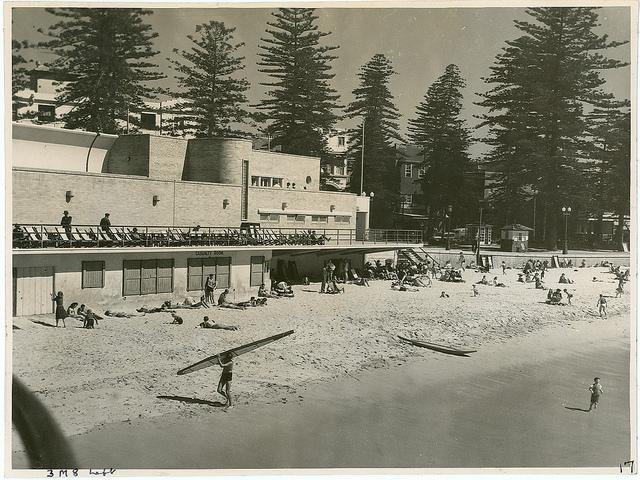Is the water choppy?
Answer briefly. No. What is the guy carrying?
Keep it brief. Surfboard. Are they at a beach?
Short answer required. Yes. Is there snow in this picture?
Answer briefly. No. 